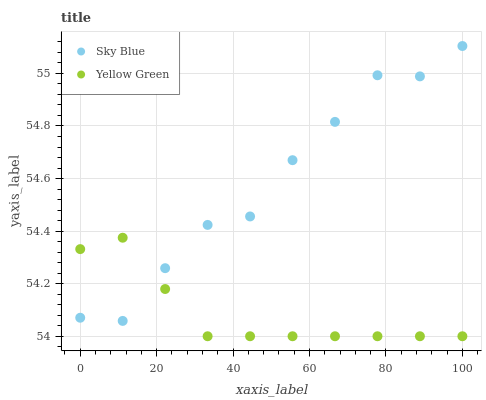Does Yellow Green have the minimum area under the curve?
Answer yes or no. Yes. Does Sky Blue have the maximum area under the curve?
Answer yes or no. Yes. Does Yellow Green have the maximum area under the curve?
Answer yes or no. No. Is Yellow Green the smoothest?
Answer yes or no. Yes. Is Sky Blue the roughest?
Answer yes or no. Yes. Is Yellow Green the roughest?
Answer yes or no. No. Does Yellow Green have the lowest value?
Answer yes or no. Yes. Does Sky Blue have the highest value?
Answer yes or no. Yes. Does Yellow Green have the highest value?
Answer yes or no. No. Does Sky Blue intersect Yellow Green?
Answer yes or no. Yes. Is Sky Blue less than Yellow Green?
Answer yes or no. No. Is Sky Blue greater than Yellow Green?
Answer yes or no. No. 